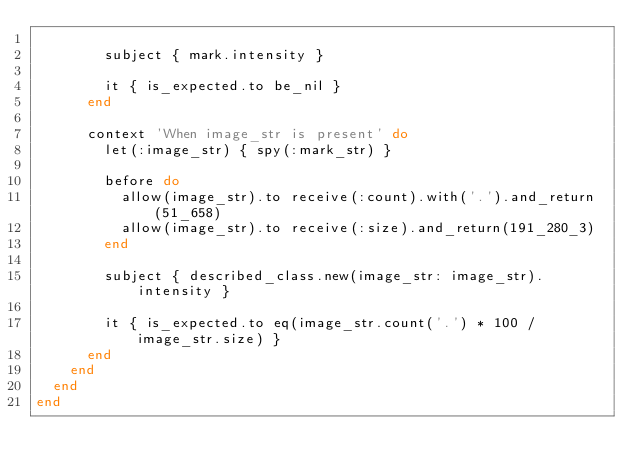<code> <loc_0><loc_0><loc_500><loc_500><_Ruby_>
        subject { mark.intensity }

        it { is_expected.to be_nil }
      end

      context 'When image_str is present' do
        let(:image_str) { spy(:mark_str) }

        before do
          allow(image_str).to receive(:count).with('.').and_return(51_658)
          allow(image_str).to receive(:size).and_return(191_280_3)
        end

        subject { described_class.new(image_str: image_str).intensity }

        it { is_expected.to eq(image_str.count('.') * 100 / image_str.size) }
      end
    end
  end
end
</code> 